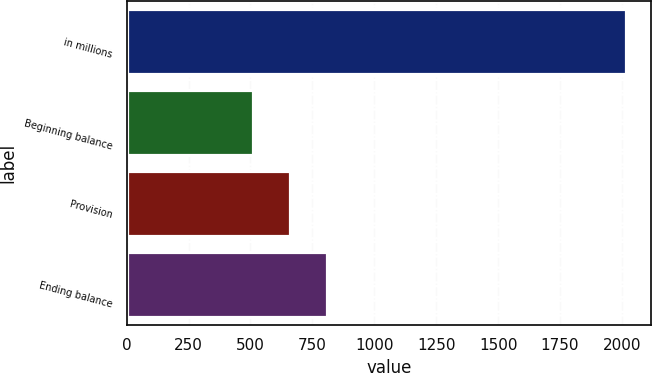Convert chart. <chart><loc_0><loc_0><loc_500><loc_500><bar_chart><fcel>in millions<fcel>Beginning balance<fcel>Provision<fcel>Ending balance<nl><fcel>2017<fcel>509<fcel>659.8<fcel>810.6<nl></chart> 